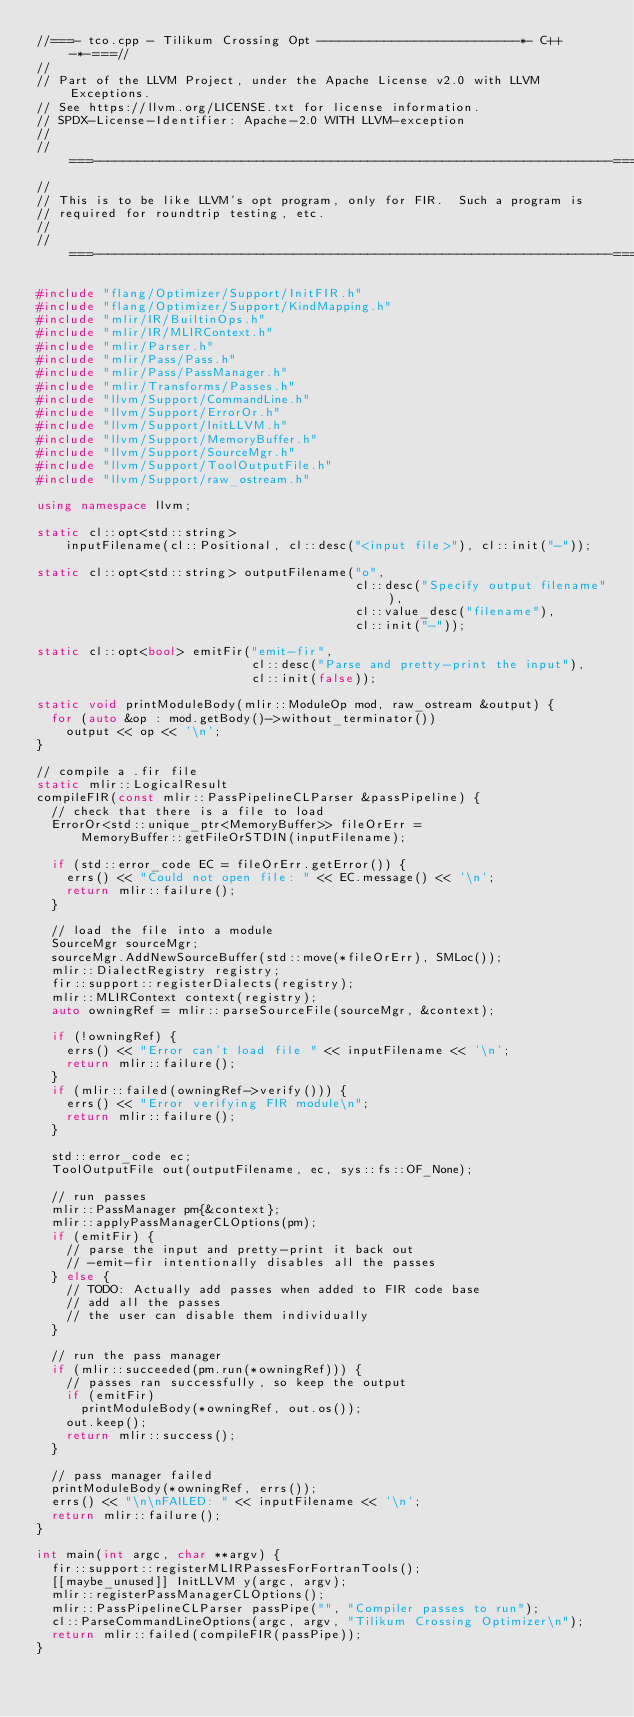Convert code to text. <code><loc_0><loc_0><loc_500><loc_500><_C++_>//===- tco.cpp - Tilikum Crossing Opt ---------------------------*- C++ -*-===//
//
// Part of the LLVM Project, under the Apache License v2.0 with LLVM Exceptions.
// See https://llvm.org/LICENSE.txt for license information.
// SPDX-License-Identifier: Apache-2.0 WITH LLVM-exception
//
//===----------------------------------------------------------------------===//
//
// This is to be like LLVM's opt program, only for FIR.  Such a program is
// required for roundtrip testing, etc.
//
//===----------------------------------------------------------------------===//

#include "flang/Optimizer/Support/InitFIR.h"
#include "flang/Optimizer/Support/KindMapping.h"
#include "mlir/IR/BuiltinOps.h"
#include "mlir/IR/MLIRContext.h"
#include "mlir/Parser.h"
#include "mlir/Pass/Pass.h"
#include "mlir/Pass/PassManager.h"
#include "mlir/Transforms/Passes.h"
#include "llvm/Support/CommandLine.h"
#include "llvm/Support/ErrorOr.h"
#include "llvm/Support/InitLLVM.h"
#include "llvm/Support/MemoryBuffer.h"
#include "llvm/Support/SourceMgr.h"
#include "llvm/Support/ToolOutputFile.h"
#include "llvm/Support/raw_ostream.h"

using namespace llvm;

static cl::opt<std::string>
    inputFilename(cl::Positional, cl::desc("<input file>"), cl::init("-"));

static cl::opt<std::string> outputFilename("o",
                                           cl::desc("Specify output filename"),
                                           cl::value_desc("filename"),
                                           cl::init("-"));

static cl::opt<bool> emitFir("emit-fir",
                             cl::desc("Parse and pretty-print the input"),
                             cl::init(false));

static void printModuleBody(mlir::ModuleOp mod, raw_ostream &output) {
  for (auto &op : mod.getBody()->without_terminator())
    output << op << '\n';
}

// compile a .fir file
static mlir::LogicalResult
compileFIR(const mlir::PassPipelineCLParser &passPipeline) {
  // check that there is a file to load
  ErrorOr<std::unique_ptr<MemoryBuffer>> fileOrErr =
      MemoryBuffer::getFileOrSTDIN(inputFilename);

  if (std::error_code EC = fileOrErr.getError()) {
    errs() << "Could not open file: " << EC.message() << '\n';
    return mlir::failure();
  }

  // load the file into a module
  SourceMgr sourceMgr;
  sourceMgr.AddNewSourceBuffer(std::move(*fileOrErr), SMLoc());
  mlir::DialectRegistry registry;
  fir::support::registerDialects(registry);
  mlir::MLIRContext context(registry);
  auto owningRef = mlir::parseSourceFile(sourceMgr, &context);

  if (!owningRef) {
    errs() << "Error can't load file " << inputFilename << '\n';
    return mlir::failure();
  }
  if (mlir::failed(owningRef->verify())) {
    errs() << "Error verifying FIR module\n";
    return mlir::failure();
  }

  std::error_code ec;
  ToolOutputFile out(outputFilename, ec, sys::fs::OF_None);

  // run passes
  mlir::PassManager pm{&context};
  mlir::applyPassManagerCLOptions(pm);
  if (emitFir) {
    // parse the input and pretty-print it back out
    // -emit-fir intentionally disables all the passes
  } else {
    // TODO: Actually add passes when added to FIR code base
    // add all the passes
    // the user can disable them individually
  }

  // run the pass manager
  if (mlir::succeeded(pm.run(*owningRef))) {
    // passes ran successfully, so keep the output
    if (emitFir)
      printModuleBody(*owningRef, out.os());
    out.keep();
    return mlir::success();
  }

  // pass manager failed
  printModuleBody(*owningRef, errs());
  errs() << "\n\nFAILED: " << inputFilename << '\n';
  return mlir::failure();
}

int main(int argc, char **argv) {
  fir::support::registerMLIRPassesForFortranTools();
  [[maybe_unused]] InitLLVM y(argc, argv);
  mlir::registerPassManagerCLOptions();
  mlir::PassPipelineCLParser passPipe("", "Compiler passes to run");
  cl::ParseCommandLineOptions(argc, argv, "Tilikum Crossing Optimizer\n");
  return mlir::failed(compileFIR(passPipe));
}
</code> 